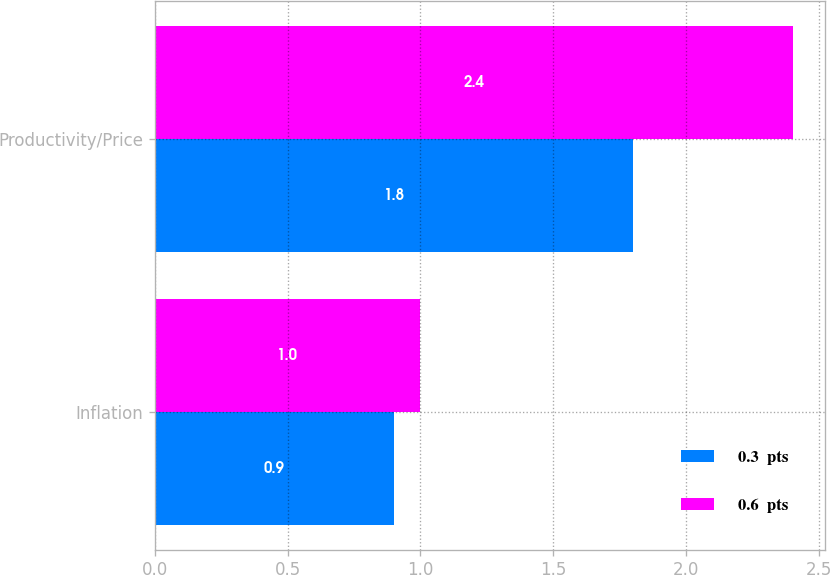<chart> <loc_0><loc_0><loc_500><loc_500><stacked_bar_chart><ecel><fcel>Inflation<fcel>Productivity/Price<nl><fcel>0.3  pts<fcel>0.9<fcel>1.8<nl><fcel>0.6  pts<fcel>1<fcel>2.4<nl></chart> 